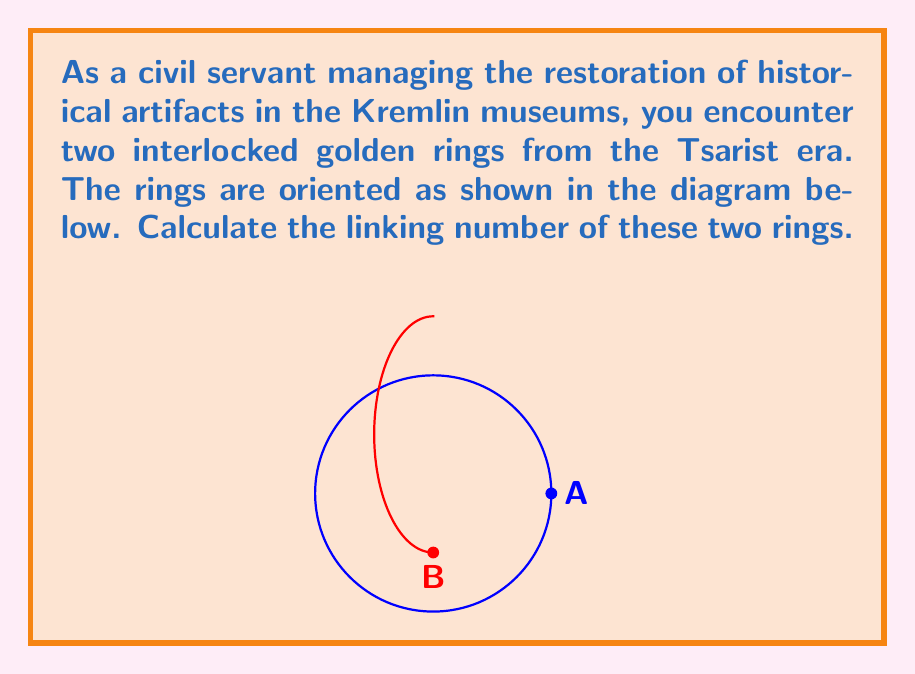Solve this math problem. To compute the linking number of two interlocked rings, we need to follow these steps:

1) Choose an orientation for each ring. Let's orient ring A counterclockwise when viewed from above, and ring B from left to right when viewed from the front.

2) Project the rings onto a plane. In this case, we'll use the xy-plane (view from above).

3) At each crossing in the projection, determine if it's a positive or negative crossing:
   - If the over-strand aligns with the under-strand's direction after a 90° counterclockwise rotation, it's a positive crossing (+1).
   - If it aligns after a 90° clockwise rotation, it's a negative crossing (-1).

4) In our projection, we see two crossings:
   - At one crossing, ring A goes over ring B: This is a positive crossing (+1).
   - At the other crossing, ring B goes over ring A: This is also a positive crossing (+1).

5) The linking number is half the sum of these crossing signs:

   $$ \text{Linking Number} = \frac{1}{2} \sum \text{(Crossing Signs)} = \frac{1}{2}(+1 +1) = +1 $$

Thus, the linking number of these two interlocked rings is +1.

Note: The linking number is an invariant, meaning it doesn't change regardless of how we deform the rings (without breaking or passing through each other). This makes it a useful measure in topology and in studying the intertwining of closed curves in three-dimensional space.
Answer: +1 